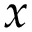Convert formula to latex. <formula><loc_0><loc_0><loc_500><loc_500>x</formula> 